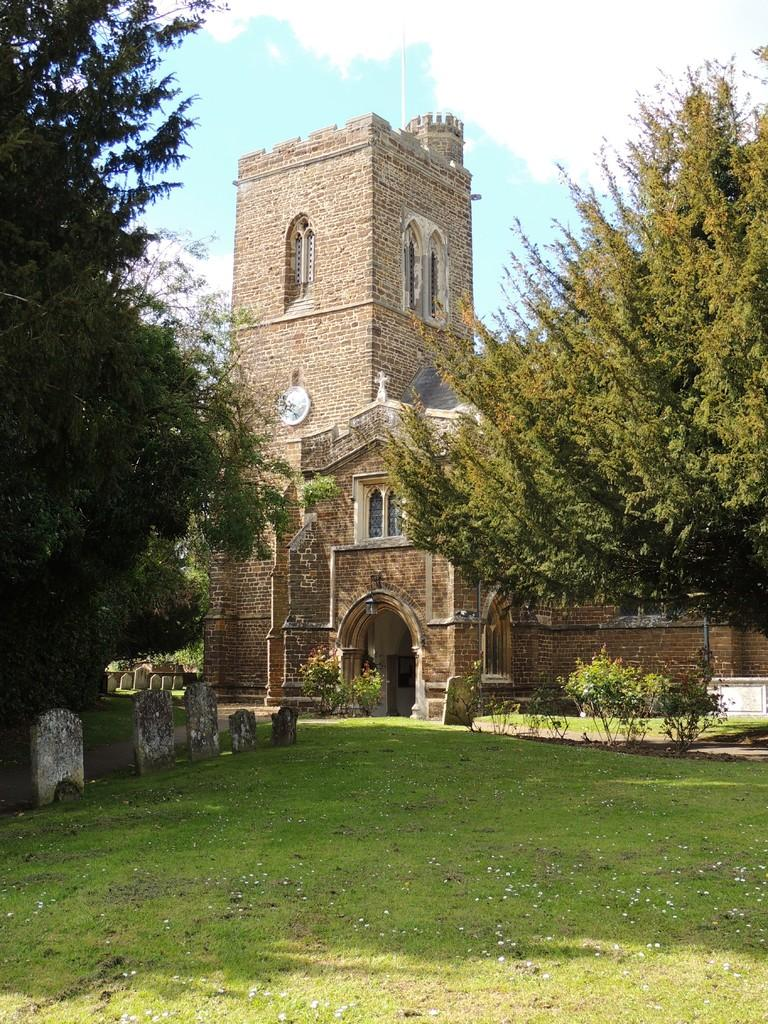What type of structure is present in the image? There is a building in the image. What is located in front of the building? There is a graveyard in front of the building. What type of vegetation can be seen in the image? There are trees and plants in the image. What is visible in the background of the image? The sky is visible in the background of the image. What type of fowl can be seen gripping the building in the image? There is no fowl present in the image, and therefore no such interaction can be observed. 